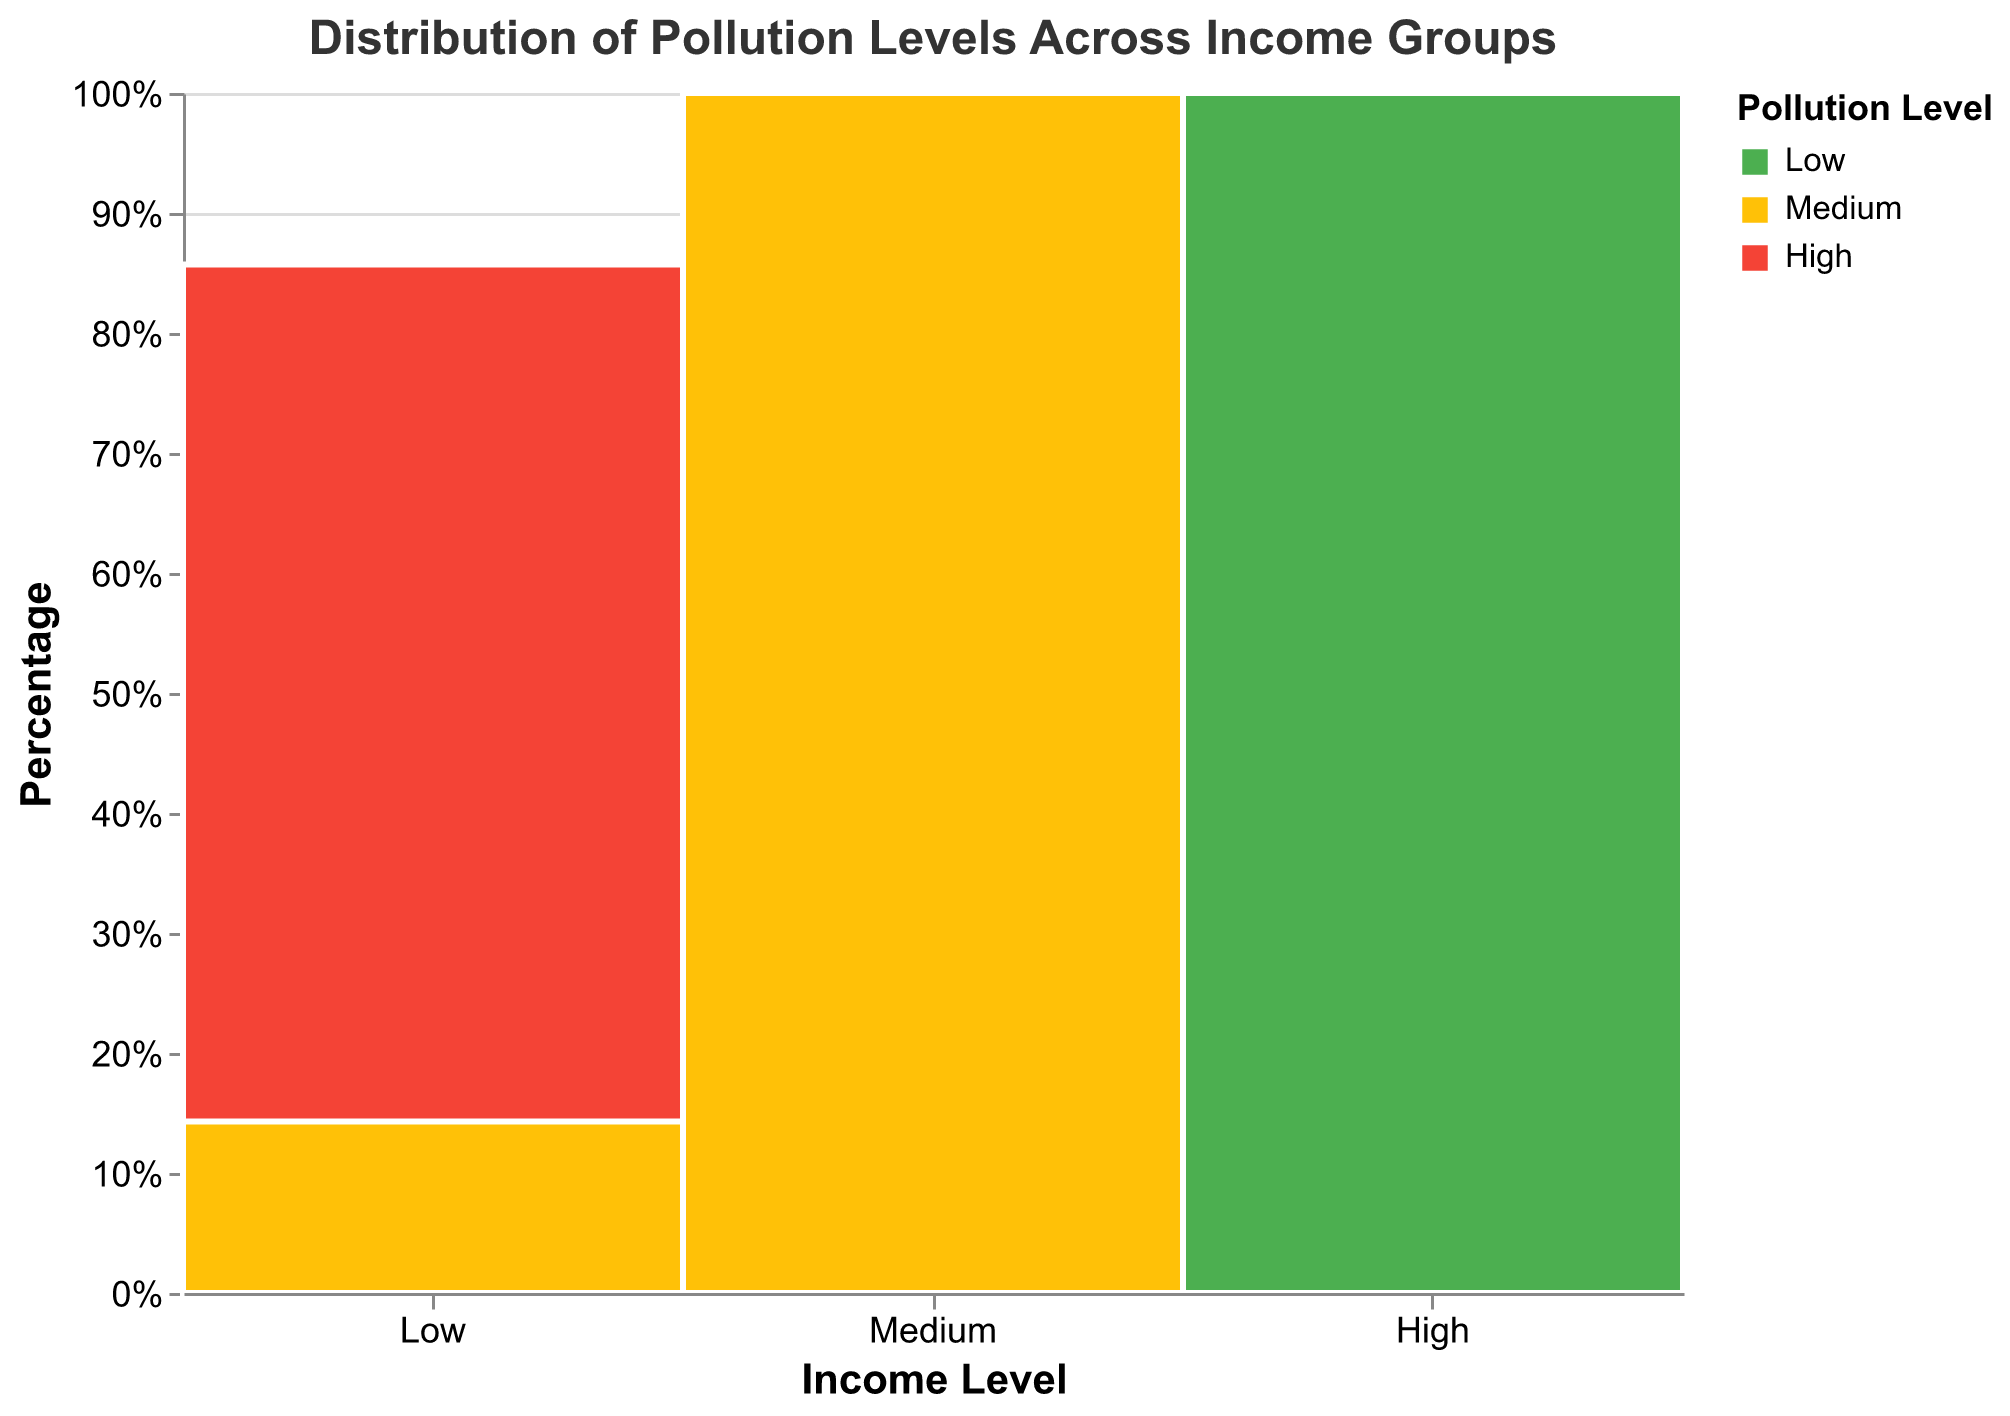What is the title of the figure? The title is located at the top of the figure and provides an overview of what the plot represents. In this case, it reads "Distribution of Pollution Levels Across Income Groups".
Answer: Distribution of Pollution Levels Across Income Groups Which income level group has the highest proportion of high pollution levels? By examining the plot, we look for the largest section of the bars colored in red (representing high pollution levels). The "Low" income level group has the largest red section.
Answer: Low What percentage of neighborhoods with medium-income levels experience medium pollution levels? To find this, look at the section of the medium income level bar that is colored in yellow (representing medium pollution levels) and read the percentage from the y-axis or tooltip.
Answer: 100% How do the pollution levels in high-income neighborhoods compare to low-income neighborhoods? Compare the color composition of the bars for high and low income levels. High-income neighborhoods predominantly have low pollution levels (green), whereas low-income neighborhoods predominantly have high pollution levels (red).
Answer: High-income neighborhoods have lower pollution levels compared to low-income neighborhoods Are any pollution levels absent in any of the income groups? Observe each bar and see if any color (green for low, yellow for medium, red for high) is missing. There are no low or medium pollution levels in low-income neighborhoods and no high pollution levels in high-income neighborhoods.
Answer: Yes Calculate the ratio of low-income neighborhoods with high pollution levels to the total number of neighborhoods. First, determine the number of low-income neighborhoods with high pollution levels, which is represented by the red section in the low-income bar. Then, count the total number of neighborhoods by examining the entire bar. The ratio is (Low-High)/(Total number).
Answer: 6/15 Which income group has the smallest proportion of low pollution levels? Look for the smallest green section among the "Low", "Medium", and "High" income groups. The "Low" income group has the smallest green section, indicating the least proportion of low pollution levels.
Answer: Low How many categories of pollution levels are there in the plot? Review the legend to see how many different pollution levels are represented by different colors. The plot displays three categories: Low (green), Medium (yellow), and High (red).
Answer: 3 Do medium-income neighborhoods experience high pollution levels? Look at the medium-income bar to see if there is any red section representing high pollution levels. There is no red section present in the medium-income group.
Answer: No 